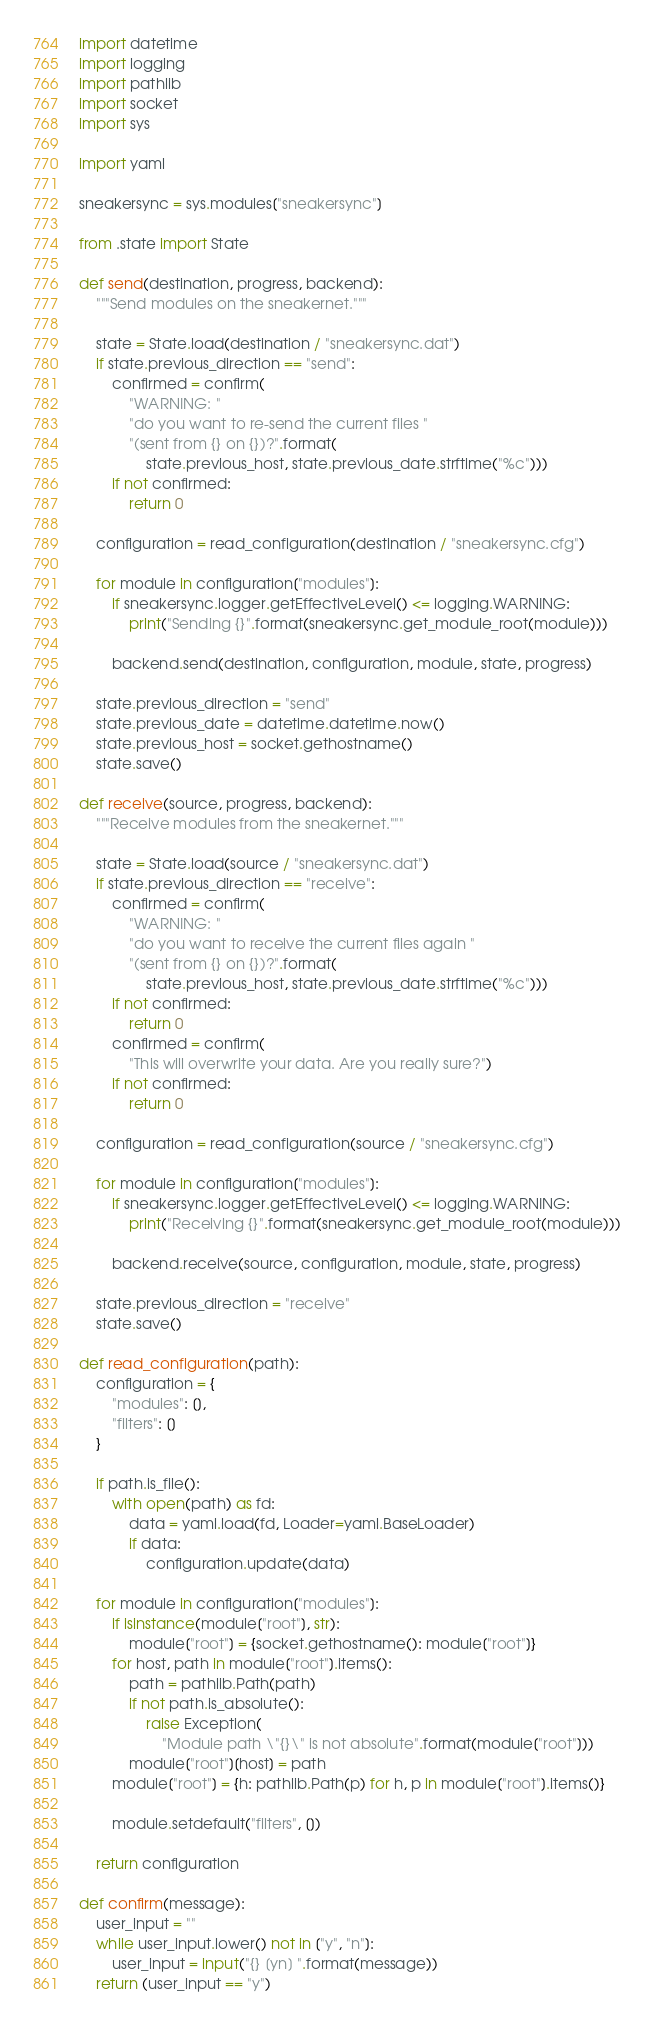<code> <loc_0><loc_0><loc_500><loc_500><_Python_>import datetime
import logging
import pathlib
import socket
import sys

import yaml

sneakersync = sys.modules["sneakersync"]

from .state import State

def send(destination, progress, backend):
    """Send modules on the sneakernet."""
    
    state = State.load(destination / "sneakersync.dat")
    if state.previous_direction == "send":
        confirmed = confirm(
            "WARNING: "
            "do you want to re-send the current files "
            "(sent from {} on {})?".format(
                state.previous_host, state.previous_date.strftime("%c")))
        if not confirmed:
            return 0
    
    configuration = read_configuration(destination / "sneakersync.cfg")
    
    for module in configuration["modules"]:
        if sneakersync.logger.getEffectiveLevel() <= logging.WARNING:
            print("Sending {}".format(sneakersync.get_module_root(module)))
        
        backend.send(destination, configuration, module, state, progress)
    
    state.previous_direction = "send"
    state.previous_date = datetime.datetime.now()
    state.previous_host = socket.gethostname()
    state.save()

def receive(source, progress, backend):
    """Receive modules from the sneakernet."""
    
    state = State.load(source / "sneakersync.dat")
    if state.previous_direction == "receive":
        confirmed = confirm(
            "WARNING: "
            "do you want to receive the current files again "
            "(sent from {} on {})?".format(
                state.previous_host, state.previous_date.strftime("%c")))
        if not confirmed:
            return 0
        confirmed = confirm(
            "This will overwrite your data. Are you really sure?")
        if not confirmed:
            return 0
    
    configuration = read_configuration(source / "sneakersync.cfg")
    
    for module in configuration["modules"]:
        if sneakersync.logger.getEffectiveLevel() <= logging.WARNING:
            print("Receiving {}".format(sneakersync.get_module_root(module)))
        
        backend.receive(source, configuration, module, state, progress)
    
    state.previous_direction = "receive"
    state.save()

def read_configuration(path):
    configuration = {
        "modules": [],
        "filters": []
    }
    
    if path.is_file():
        with open(path) as fd:
            data = yaml.load(fd, Loader=yaml.BaseLoader)
            if data:
                configuration.update(data)
    
    for module in configuration["modules"]:
        if isinstance(module["root"], str):
            module["root"] = {socket.gethostname(): module["root"]}
        for host, path in module["root"].items():
            path = pathlib.Path(path)
            if not path.is_absolute():
                raise Exception(
                    "Module path \"{}\" is not absolute".format(module["root"]))
            module["root"][host] = path
        module["root"] = {h: pathlib.Path(p) for h, p in module["root"].items()}
        
        module.setdefault("filters", [])
    
    return configuration

def confirm(message):
    user_input = ""
    while user_input.lower() not in ["y", "n"]: 
        user_input = input("{} [yn] ".format(message))
    return (user_input == "y")
</code> 